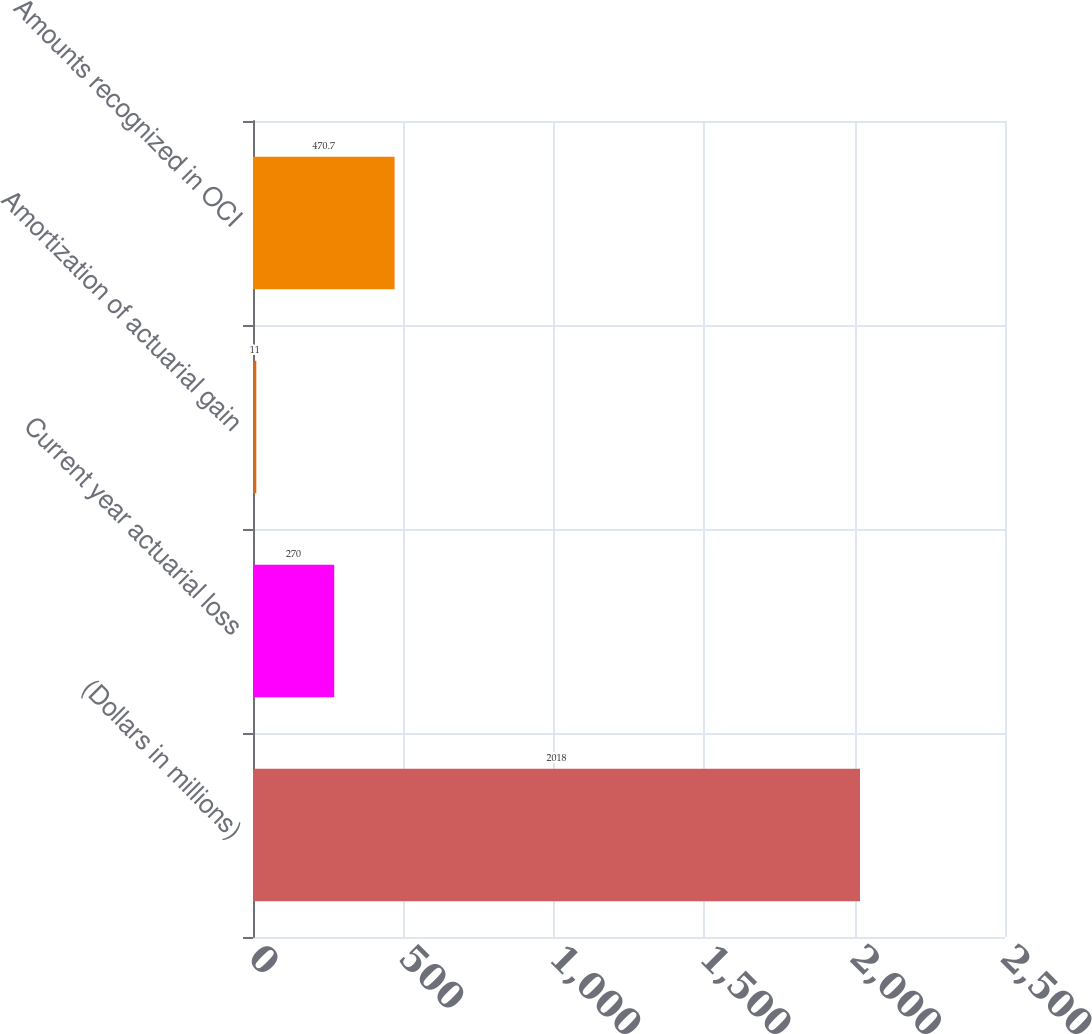Convert chart to OTSL. <chart><loc_0><loc_0><loc_500><loc_500><bar_chart><fcel>(Dollars in millions)<fcel>Current year actuarial loss<fcel>Amortization of actuarial gain<fcel>Amounts recognized in OCI<nl><fcel>2018<fcel>270<fcel>11<fcel>470.7<nl></chart> 